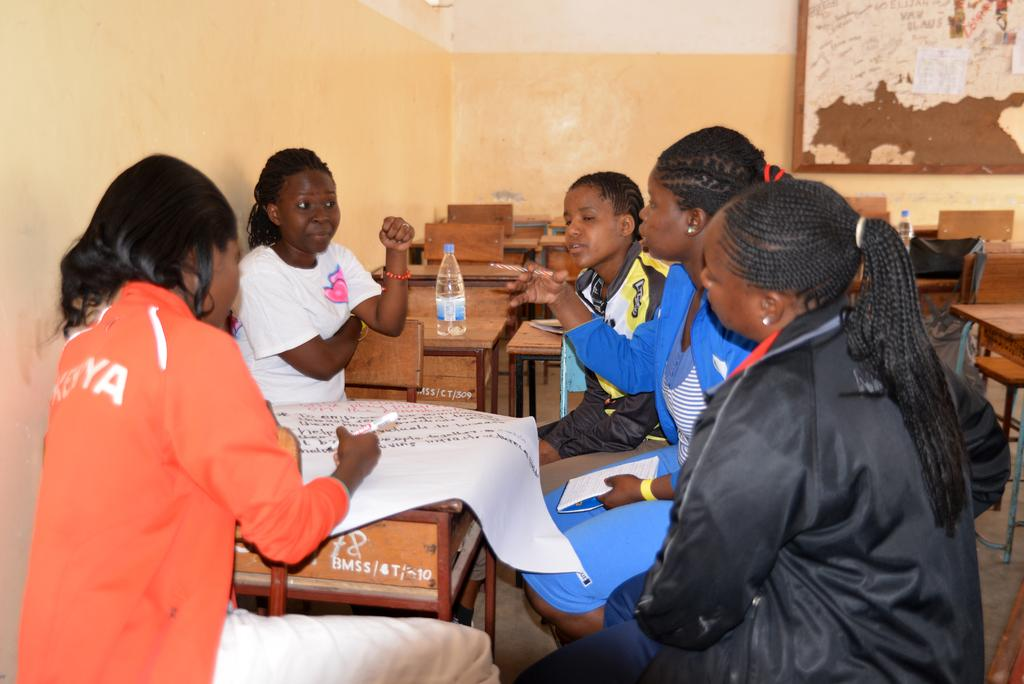What is the main subject of the image? The main subject of the image is a group of women. What are the women doing in the image? The women are sitting on chairs, and one woman is writing on a chart. Can you describe the table in the image? There is a bottle placed on a table in the image. What color is the wall in the image? The wall is yellow colored. How many deer can be seen in the image? There are no deer present in the image. What type of basin is used by the women in the image? There is no basin visible in the image; it only shows a group of women sitting on chairs, one of whom is writing on a chart. 